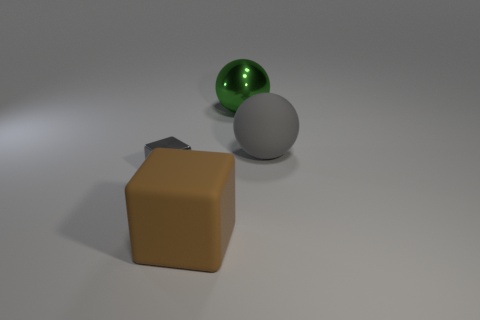Does the tiny metallic cube have the same color as the large matte ball?
Offer a very short reply. Yes. Does the big rubber thing behind the small shiny block have the same color as the tiny shiny cube on the left side of the big green sphere?
Offer a terse response. Yes. What is the color of the thing that is both in front of the big green metallic ball and on the right side of the large cube?
Provide a short and direct response. Gray. Does the gray cube have the same material as the green sphere?
Your answer should be compact. Yes. What number of large objects are purple metal blocks or gray metallic cubes?
Provide a short and direct response. 0. Is there anything else that has the same size as the gray metallic block?
Make the answer very short. No. There is a tiny block that is the same material as the green sphere; what is its color?
Ensure brevity in your answer.  Gray. There is a metal object that is behind the tiny gray block; what color is it?
Give a very brief answer. Green. What number of objects have the same color as the matte sphere?
Your response must be concise. 1. Is the number of gray matte things behind the big metal ball less than the number of things behind the tiny metallic block?
Give a very brief answer. Yes. 